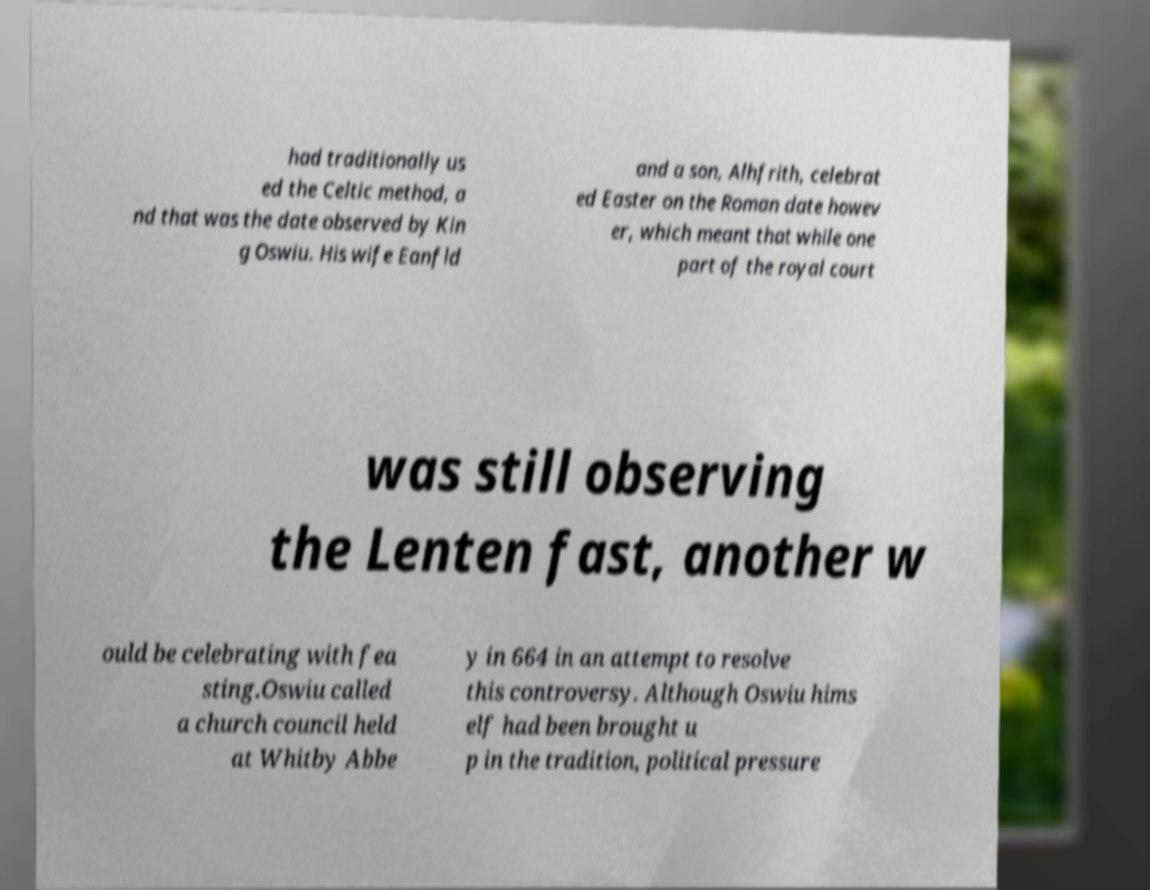Could you assist in decoding the text presented in this image and type it out clearly? had traditionally us ed the Celtic method, a nd that was the date observed by Kin g Oswiu. His wife Eanfld and a son, Alhfrith, celebrat ed Easter on the Roman date howev er, which meant that while one part of the royal court was still observing the Lenten fast, another w ould be celebrating with fea sting.Oswiu called a church council held at Whitby Abbe y in 664 in an attempt to resolve this controversy. Although Oswiu hims elf had been brought u p in the tradition, political pressure 